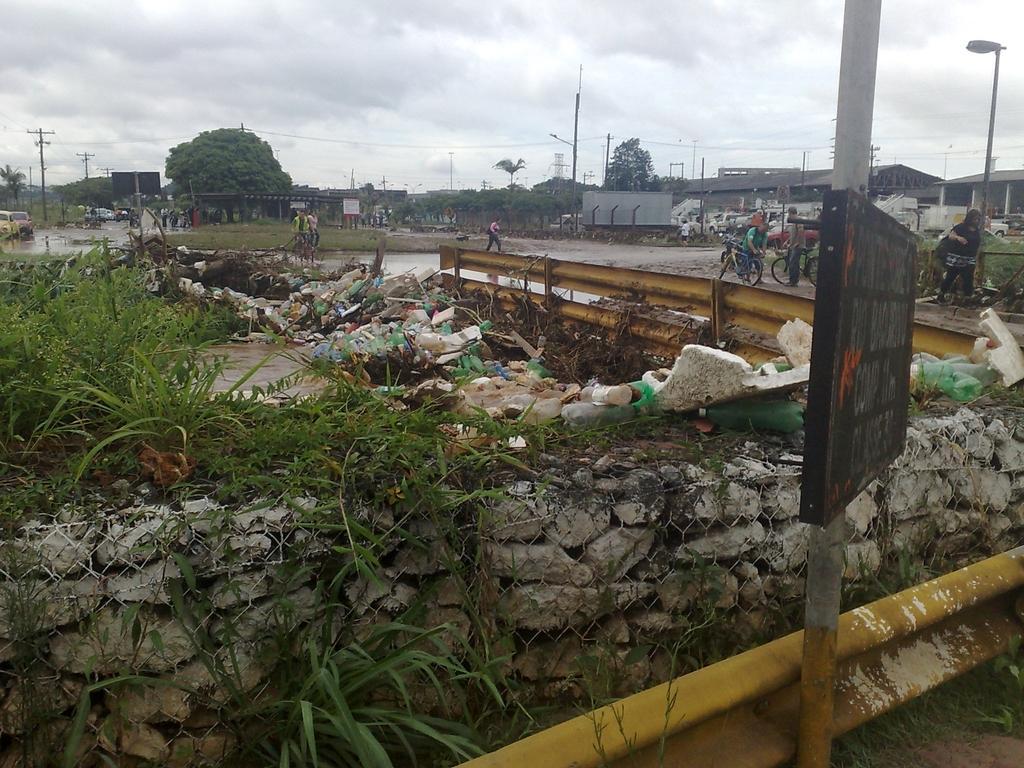Could you give a brief overview of what you see in this image? In this picture we can observe a fence and a stone wall. There is yellow color railing. We can observe a black color board fixed to this pole. There are some plants and garbage. We can observe a road here. There are some people standing. In the background there are trees and buildings. There is a sky with clouds. 